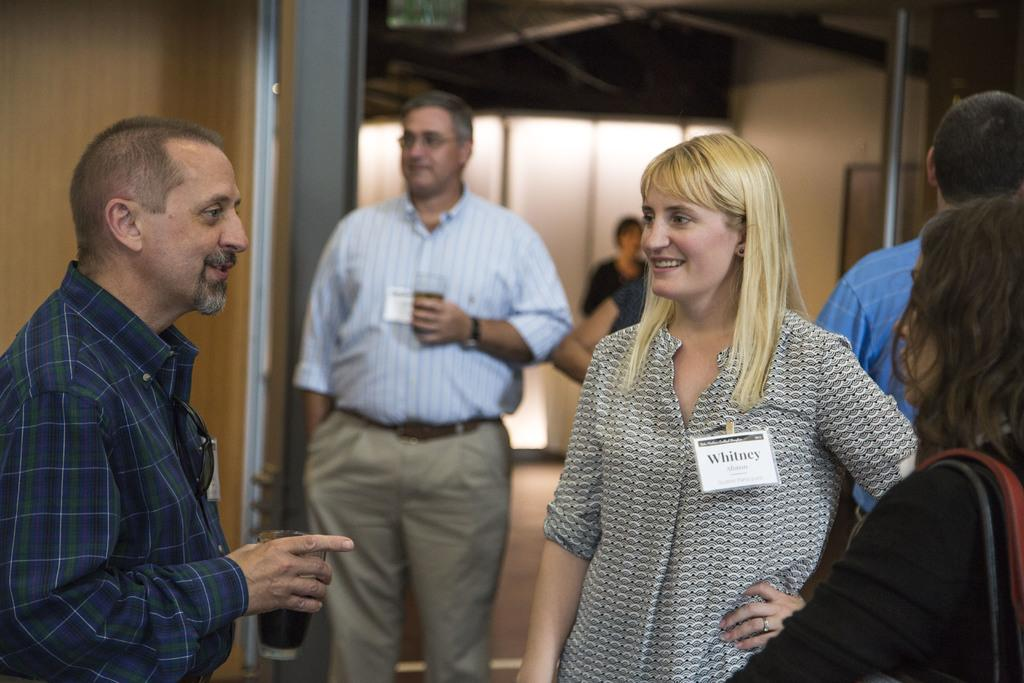What can be seen in the image? There are people standing in the image. Where are the people standing? The people are standing on the floor. What are some of the people holding in their hands? Some of the people are holding glass tumblers in their hands. How many times do the people shake their hands in the image? There is no indication in the image that the people are shaking their hands, so it cannot be determined from the picture. 